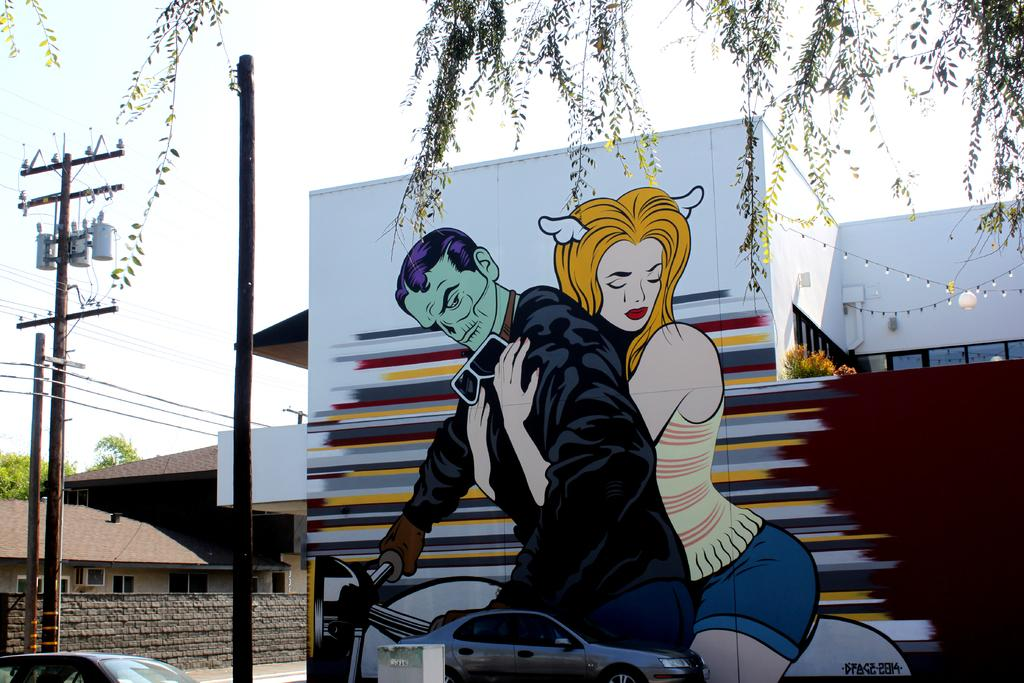What is depicted on the wall in the image? There is a painting on the wall in the image. What type of structures can be seen in the image? There are houses in the image. What objects are present in the image that are used for support or signage? There are poles in the image. What type of transportation is visible in the image? There are vehicles in the image. What can be seen in the background of the image? The sky is visible in the background of the image. What type of glove is being used to represent the territory in the image? There is no glove present in the image, nor is there any representation of territory. 